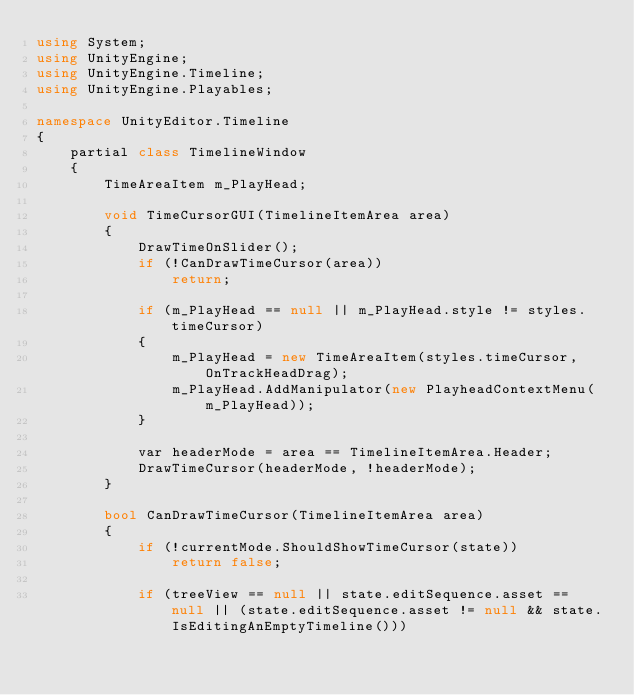<code> <loc_0><loc_0><loc_500><loc_500><_C#_>using System;
using UnityEngine;
using UnityEngine.Timeline;
using UnityEngine.Playables;

namespace UnityEditor.Timeline
{
    partial class TimelineWindow
    {
        TimeAreaItem m_PlayHead;

        void TimeCursorGUI(TimelineItemArea area)
        {
            DrawTimeOnSlider();
            if (!CanDrawTimeCursor(area))
                return;

            if (m_PlayHead == null || m_PlayHead.style != styles.timeCursor)
            {
                m_PlayHead = new TimeAreaItem(styles.timeCursor, OnTrackHeadDrag);
                m_PlayHead.AddManipulator(new PlayheadContextMenu(m_PlayHead));
            }

            var headerMode = area == TimelineItemArea.Header;
            DrawTimeCursor(headerMode, !headerMode);
        }

        bool CanDrawTimeCursor(TimelineItemArea area)
        {
            if (!currentMode.ShouldShowTimeCursor(state))
                return false;

            if (treeView == null || state.editSequence.asset == null || (state.editSequence.asset != null && state.IsEditingAnEmptyTimeline()))</code> 